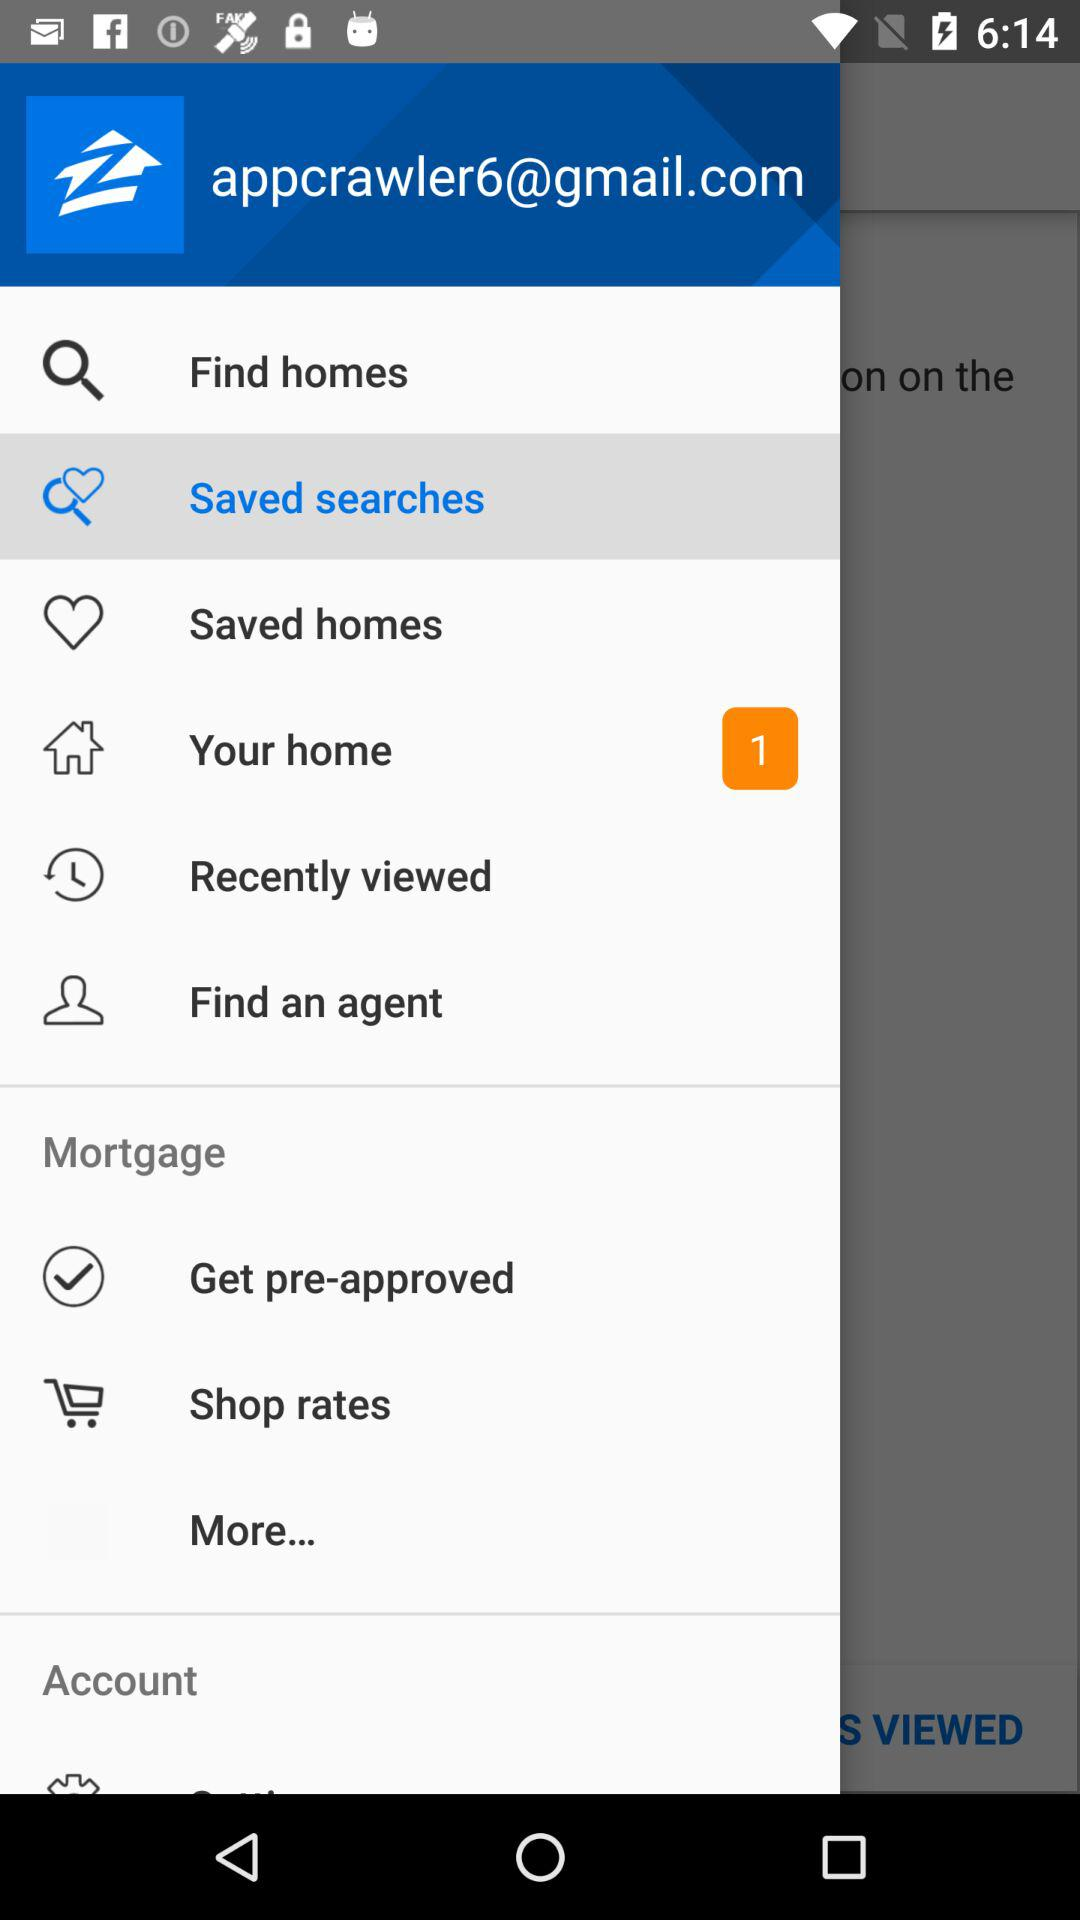Which item is selected? The selected item is "Saved searches". 